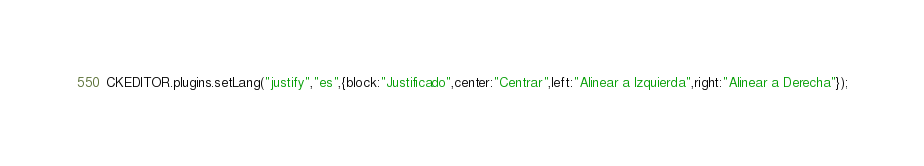Convert code to text. <code><loc_0><loc_0><loc_500><loc_500><_JavaScript_>CKEDITOR.plugins.setLang("justify","es",{block:"Justificado",center:"Centrar",left:"Alinear a Izquierda",right:"Alinear a Derecha"});</code> 